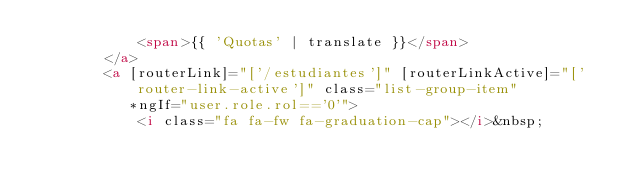<code> <loc_0><loc_0><loc_500><loc_500><_HTML_>            <span>{{ 'Quotas' | translate }}</span>
        </a>
        <a [routerLink]="['/estudiantes']" [routerLinkActive]="['router-link-active']" class="list-group-item"
           *ngIf="user.role.rol=='0'">
            <i class="fa fa-fw fa-graduation-cap"></i>&nbsp;</code> 